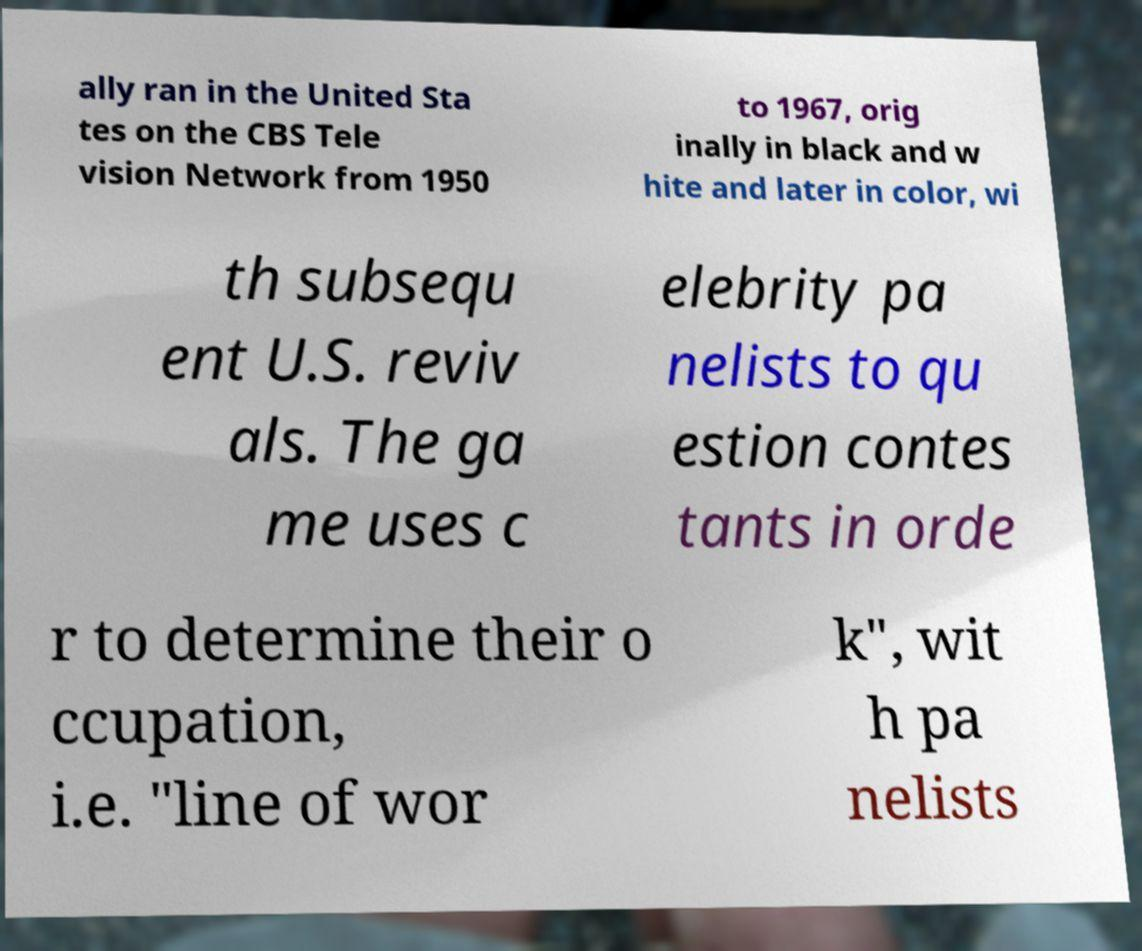I need the written content from this picture converted into text. Can you do that? ally ran in the United Sta tes on the CBS Tele vision Network from 1950 to 1967, orig inally in black and w hite and later in color, wi th subsequ ent U.S. reviv als. The ga me uses c elebrity pa nelists to qu estion contes tants in orde r to determine their o ccupation, i.e. "line of wor k", wit h pa nelists 